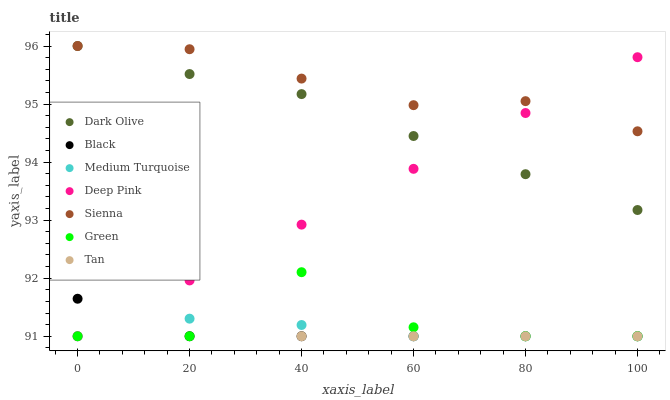Does Black have the minimum area under the curve?
Answer yes or no. Yes. Does Sienna have the maximum area under the curve?
Answer yes or no. Yes. Does Dark Olive have the minimum area under the curve?
Answer yes or no. No. Does Dark Olive have the maximum area under the curve?
Answer yes or no. No. Is Deep Pink the smoothest?
Answer yes or no. Yes. Is Green the roughest?
Answer yes or no. Yes. Is Dark Olive the smoothest?
Answer yes or no. No. Is Dark Olive the roughest?
Answer yes or no. No. Does Deep Pink have the lowest value?
Answer yes or no. Yes. Does Dark Olive have the lowest value?
Answer yes or no. No. Does Sienna have the highest value?
Answer yes or no. Yes. Does Green have the highest value?
Answer yes or no. No. Is Black less than Dark Olive?
Answer yes or no. Yes. Is Dark Olive greater than Green?
Answer yes or no. Yes. Does Tan intersect Deep Pink?
Answer yes or no. Yes. Is Tan less than Deep Pink?
Answer yes or no. No. Is Tan greater than Deep Pink?
Answer yes or no. No. Does Black intersect Dark Olive?
Answer yes or no. No. 